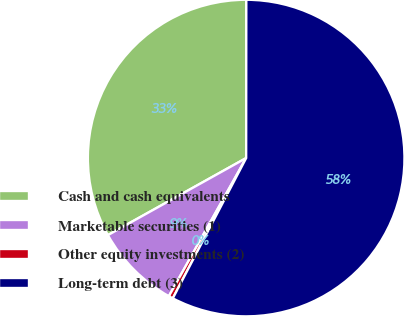<chart> <loc_0><loc_0><loc_500><loc_500><pie_chart><fcel>Cash and cash equivalents<fcel>Marketable securities (1)<fcel>Other equity investments (2)<fcel>Long-term debt (3)<nl><fcel>33.11%<fcel>8.79%<fcel>0.45%<fcel>57.66%<nl></chart> 